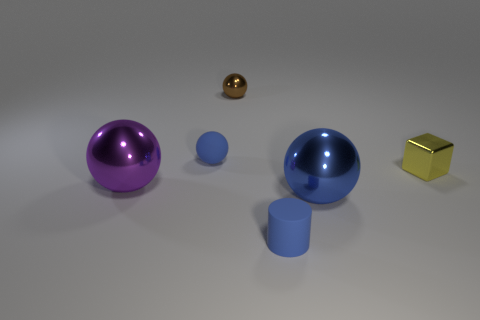Subtract all cyan balls. Subtract all yellow blocks. How many balls are left? 4 Add 1 tiny metal blocks. How many objects exist? 7 Subtract all blocks. How many objects are left? 5 Add 1 tiny cyan rubber blocks. How many tiny cyan rubber blocks exist? 1 Subtract 1 blue cylinders. How many objects are left? 5 Subtract all brown cylinders. Subtract all large things. How many objects are left? 4 Add 4 yellow objects. How many yellow objects are left? 5 